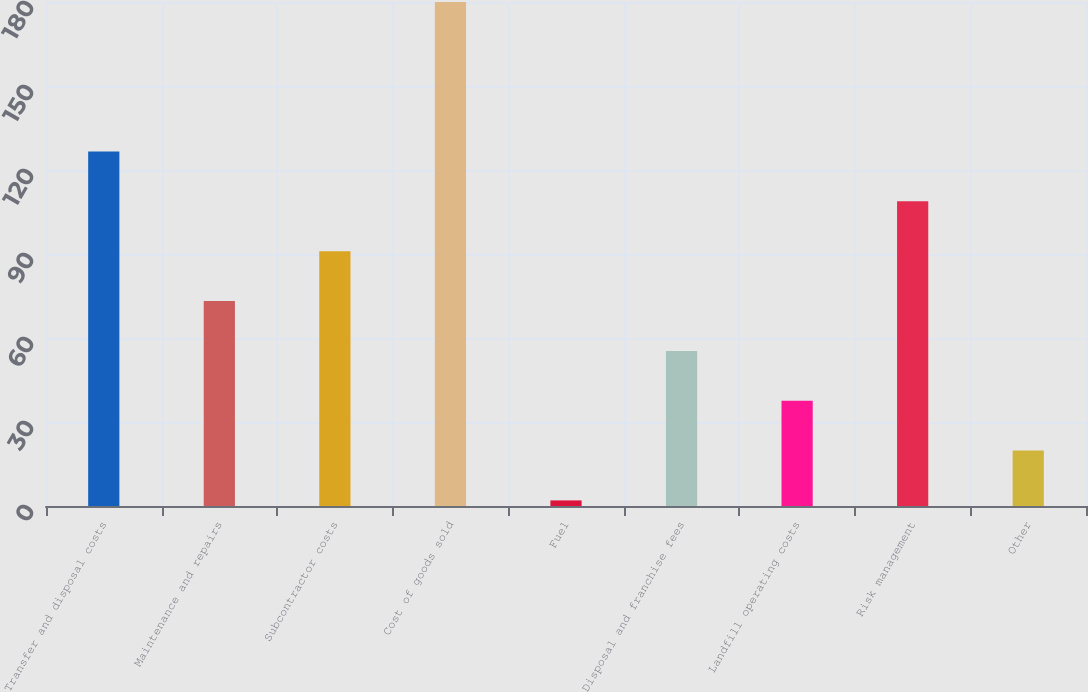Convert chart to OTSL. <chart><loc_0><loc_0><loc_500><loc_500><bar_chart><fcel>Transfer and disposal costs<fcel>Maintenance and repairs<fcel>Subcontractor costs<fcel>Cost of goods sold<fcel>Fuel<fcel>Disposal and franchise fees<fcel>Landfill operating costs<fcel>Risk management<fcel>Other<nl><fcel>126.6<fcel>73.2<fcel>91<fcel>180<fcel>2<fcel>55.4<fcel>37.6<fcel>108.8<fcel>19.8<nl></chart> 